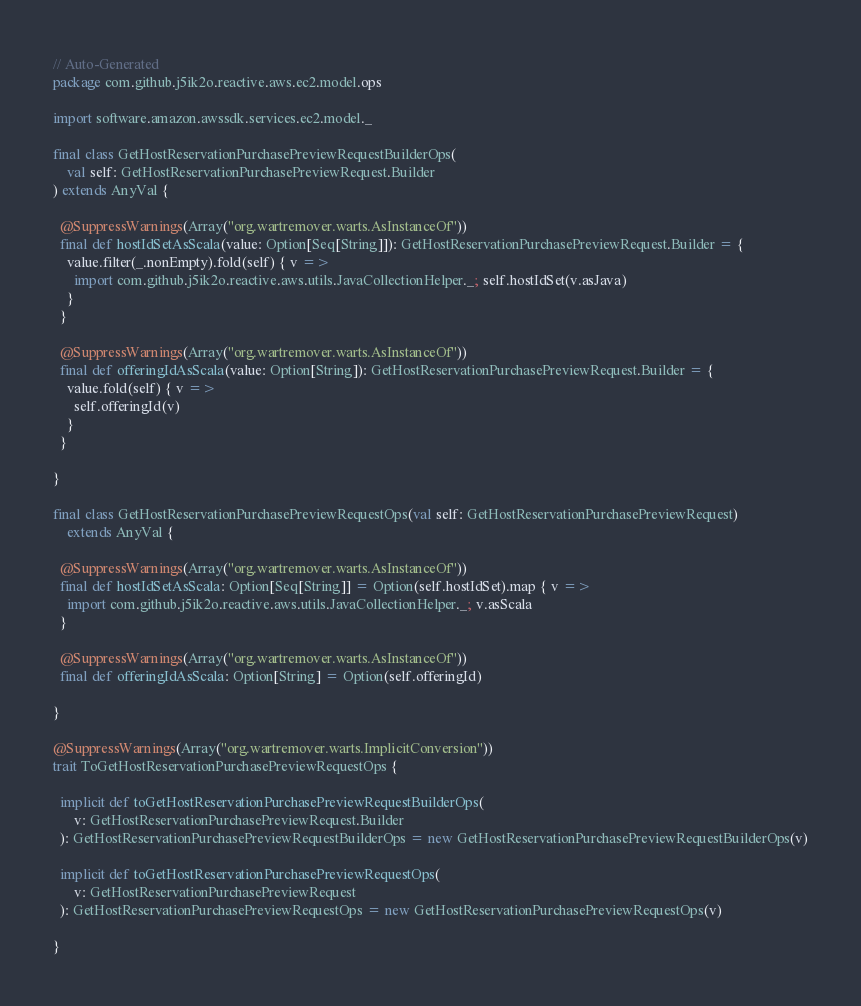<code> <loc_0><loc_0><loc_500><loc_500><_Scala_>// Auto-Generated
package com.github.j5ik2o.reactive.aws.ec2.model.ops

import software.amazon.awssdk.services.ec2.model._

final class GetHostReservationPurchasePreviewRequestBuilderOps(
    val self: GetHostReservationPurchasePreviewRequest.Builder
) extends AnyVal {

  @SuppressWarnings(Array("org.wartremover.warts.AsInstanceOf"))
  final def hostIdSetAsScala(value: Option[Seq[String]]): GetHostReservationPurchasePreviewRequest.Builder = {
    value.filter(_.nonEmpty).fold(self) { v =>
      import com.github.j5ik2o.reactive.aws.utils.JavaCollectionHelper._; self.hostIdSet(v.asJava)
    }
  }

  @SuppressWarnings(Array("org.wartremover.warts.AsInstanceOf"))
  final def offeringIdAsScala(value: Option[String]): GetHostReservationPurchasePreviewRequest.Builder = {
    value.fold(self) { v =>
      self.offeringId(v)
    }
  }

}

final class GetHostReservationPurchasePreviewRequestOps(val self: GetHostReservationPurchasePreviewRequest)
    extends AnyVal {

  @SuppressWarnings(Array("org.wartremover.warts.AsInstanceOf"))
  final def hostIdSetAsScala: Option[Seq[String]] = Option(self.hostIdSet).map { v =>
    import com.github.j5ik2o.reactive.aws.utils.JavaCollectionHelper._; v.asScala
  }

  @SuppressWarnings(Array("org.wartremover.warts.AsInstanceOf"))
  final def offeringIdAsScala: Option[String] = Option(self.offeringId)

}

@SuppressWarnings(Array("org.wartremover.warts.ImplicitConversion"))
trait ToGetHostReservationPurchasePreviewRequestOps {

  implicit def toGetHostReservationPurchasePreviewRequestBuilderOps(
      v: GetHostReservationPurchasePreviewRequest.Builder
  ): GetHostReservationPurchasePreviewRequestBuilderOps = new GetHostReservationPurchasePreviewRequestBuilderOps(v)

  implicit def toGetHostReservationPurchasePreviewRequestOps(
      v: GetHostReservationPurchasePreviewRequest
  ): GetHostReservationPurchasePreviewRequestOps = new GetHostReservationPurchasePreviewRequestOps(v)

}
</code> 